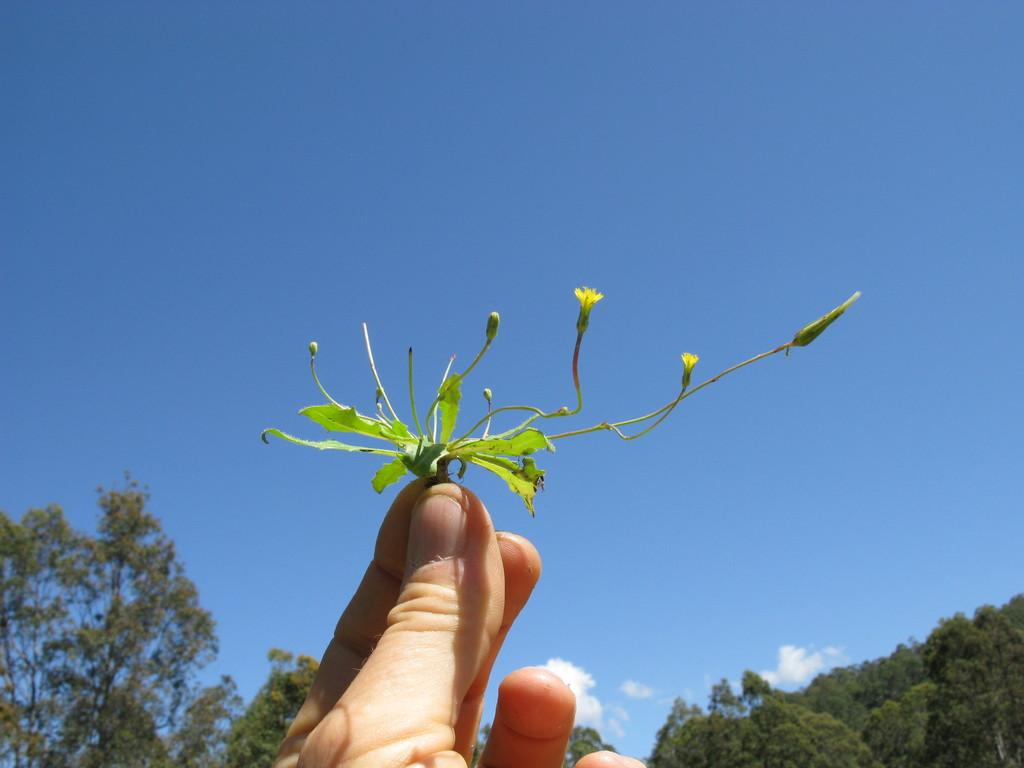What is the person holding in the image? There is a person's hand holding flowers and leaves in the image. What can be seen in the background of the image? There are trees and the sky visible in the background of the image. How many robins are perched on the dock in the image? There are no robins or docks present in the image. What type of mice can be seen scurrying around the person's hand in the image? There are no mice present in the image; it only shows a person's hand holding flowers and leaves. 